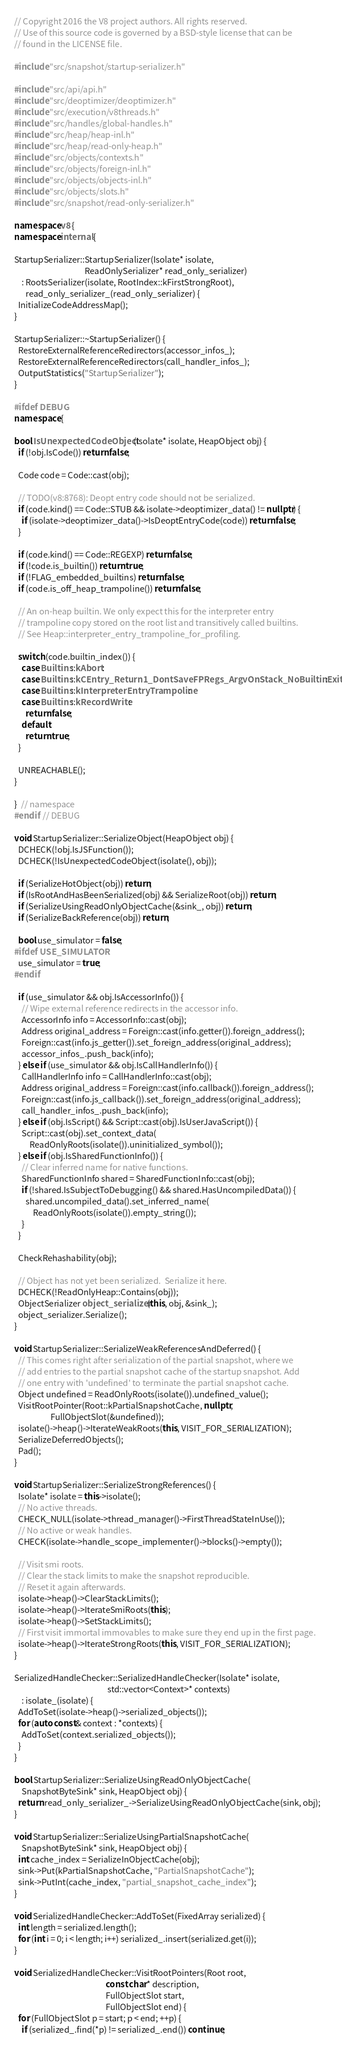<code> <loc_0><loc_0><loc_500><loc_500><_C++_>// Copyright 2016 the V8 project authors. All rights reserved.
// Use of this source code is governed by a BSD-style license that can be
// found in the LICENSE file.

#include "src/snapshot/startup-serializer.h"

#include "src/api/api.h"
#include "src/deoptimizer/deoptimizer.h"
#include "src/execution/v8threads.h"
#include "src/handles/global-handles.h"
#include "src/heap/heap-inl.h"
#include "src/heap/read-only-heap.h"
#include "src/objects/contexts.h"
#include "src/objects/foreign-inl.h"
#include "src/objects/objects-inl.h"
#include "src/objects/slots.h"
#include "src/snapshot/read-only-serializer.h"

namespace v8 {
namespace internal {

StartupSerializer::StartupSerializer(Isolate* isolate,
                                     ReadOnlySerializer* read_only_serializer)
    : RootsSerializer(isolate, RootIndex::kFirstStrongRoot),
      read_only_serializer_(read_only_serializer) {
  InitializeCodeAddressMap();
}

StartupSerializer::~StartupSerializer() {
  RestoreExternalReferenceRedirectors(accessor_infos_);
  RestoreExternalReferenceRedirectors(call_handler_infos_);
  OutputStatistics("StartupSerializer");
}

#ifdef DEBUG
namespace {

bool IsUnexpectedCodeObject(Isolate* isolate, HeapObject obj) {
  if (!obj.IsCode()) return false;

  Code code = Code::cast(obj);

  // TODO(v8:8768): Deopt entry code should not be serialized.
  if (code.kind() == Code::STUB && isolate->deoptimizer_data() != nullptr) {
    if (isolate->deoptimizer_data()->IsDeoptEntryCode(code)) return false;
  }

  if (code.kind() == Code::REGEXP) return false;
  if (!code.is_builtin()) return true;
  if (!FLAG_embedded_builtins) return false;
  if (code.is_off_heap_trampoline()) return false;

  // An on-heap builtin. We only expect this for the interpreter entry
  // trampoline copy stored on the root list and transitively called builtins.
  // See Heap::interpreter_entry_trampoline_for_profiling.

  switch (code.builtin_index()) {
    case Builtins::kAbort:
    case Builtins::kCEntry_Return1_DontSaveFPRegs_ArgvOnStack_NoBuiltinExit:
    case Builtins::kInterpreterEntryTrampoline:
    case Builtins::kRecordWrite:
      return false;
    default:
      return true;
  }

  UNREACHABLE();
}

}  // namespace
#endif  // DEBUG

void StartupSerializer::SerializeObject(HeapObject obj) {
  DCHECK(!obj.IsJSFunction());
  DCHECK(!IsUnexpectedCodeObject(isolate(), obj));

  if (SerializeHotObject(obj)) return;
  if (IsRootAndHasBeenSerialized(obj) && SerializeRoot(obj)) return;
  if (SerializeUsingReadOnlyObjectCache(&sink_, obj)) return;
  if (SerializeBackReference(obj)) return;

  bool use_simulator = false;
#ifdef USE_SIMULATOR
  use_simulator = true;
#endif

  if (use_simulator && obj.IsAccessorInfo()) {
    // Wipe external reference redirects in the accessor info.
    AccessorInfo info = AccessorInfo::cast(obj);
    Address original_address = Foreign::cast(info.getter()).foreign_address();
    Foreign::cast(info.js_getter()).set_foreign_address(original_address);
    accessor_infos_.push_back(info);
  } else if (use_simulator && obj.IsCallHandlerInfo()) {
    CallHandlerInfo info = CallHandlerInfo::cast(obj);
    Address original_address = Foreign::cast(info.callback()).foreign_address();
    Foreign::cast(info.js_callback()).set_foreign_address(original_address);
    call_handler_infos_.push_back(info);
  } else if (obj.IsScript() && Script::cast(obj).IsUserJavaScript()) {
    Script::cast(obj).set_context_data(
        ReadOnlyRoots(isolate()).uninitialized_symbol());
  } else if (obj.IsSharedFunctionInfo()) {
    // Clear inferred name for native functions.
    SharedFunctionInfo shared = SharedFunctionInfo::cast(obj);
    if (!shared.IsSubjectToDebugging() && shared.HasUncompiledData()) {
      shared.uncompiled_data().set_inferred_name(
          ReadOnlyRoots(isolate()).empty_string());
    }
  }

  CheckRehashability(obj);

  // Object has not yet been serialized.  Serialize it here.
  DCHECK(!ReadOnlyHeap::Contains(obj));
  ObjectSerializer object_serializer(this, obj, &sink_);
  object_serializer.Serialize();
}

void StartupSerializer::SerializeWeakReferencesAndDeferred() {
  // This comes right after serialization of the partial snapshot, where we
  // add entries to the partial snapshot cache of the startup snapshot. Add
  // one entry with 'undefined' to terminate the partial snapshot cache.
  Object undefined = ReadOnlyRoots(isolate()).undefined_value();
  VisitRootPointer(Root::kPartialSnapshotCache, nullptr,
                   FullObjectSlot(&undefined));
  isolate()->heap()->IterateWeakRoots(this, VISIT_FOR_SERIALIZATION);
  SerializeDeferredObjects();
  Pad();
}

void StartupSerializer::SerializeStrongReferences() {
  Isolate* isolate = this->isolate();
  // No active threads.
  CHECK_NULL(isolate->thread_manager()->FirstThreadStateInUse());
  // No active or weak handles.
  CHECK(isolate->handle_scope_implementer()->blocks()->empty());

  // Visit smi roots.
  // Clear the stack limits to make the snapshot reproducible.
  // Reset it again afterwards.
  isolate->heap()->ClearStackLimits();
  isolate->heap()->IterateSmiRoots(this);
  isolate->heap()->SetStackLimits();
  // First visit immortal immovables to make sure they end up in the first page.
  isolate->heap()->IterateStrongRoots(this, VISIT_FOR_SERIALIZATION);
}

SerializedHandleChecker::SerializedHandleChecker(Isolate* isolate,
                                                 std::vector<Context>* contexts)
    : isolate_(isolate) {
  AddToSet(isolate->heap()->serialized_objects());
  for (auto const& context : *contexts) {
    AddToSet(context.serialized_objects());
  }
}

bool StartupSerializer::SerializeUsingReadOnlyObjectCache(
    SnapshotByteSink* sink, HeapObject obj) {
  return read_only_serializer_->SerializeUsingReadOnlyObjectCache(sink, obj);
}

void StartupSerializer::SerializeUsingPartialSnapshotCache(
    SnapshotByteSink* sink, HeapObject obj) {
  int cache_index = SerializeInObjectCache(obj);
  sink->Put(kPartialSnapshotCache, "PartialSnapshotCache");
  sink->PutInt(cache_index, "partial_snapshot_cache_index");
}

void SerializedHandleChecker::AddToSet(FixedArray serialized) {
  int length = serialized.length();
  for (int i = 0; i < length; i++) serialized_.insert(serialized.get(i));
}

void SerializedHandleChecker::VisitRootPointers(Root root,
                                                const char* description,
                                                FullObjectSlot start,
                                                FullObjectSlot end) {
  for (FullObjectSlot p = start; p < end; ++p) {
    if (serialized_.find(*p) != serialized_.end()) continue;</code> 